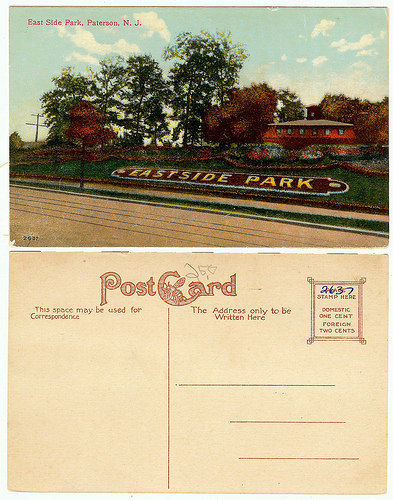<image>
Is the post card under the photo? Yes. The post card is positioned underneath the photo, with the photo above it in the vertical space. 